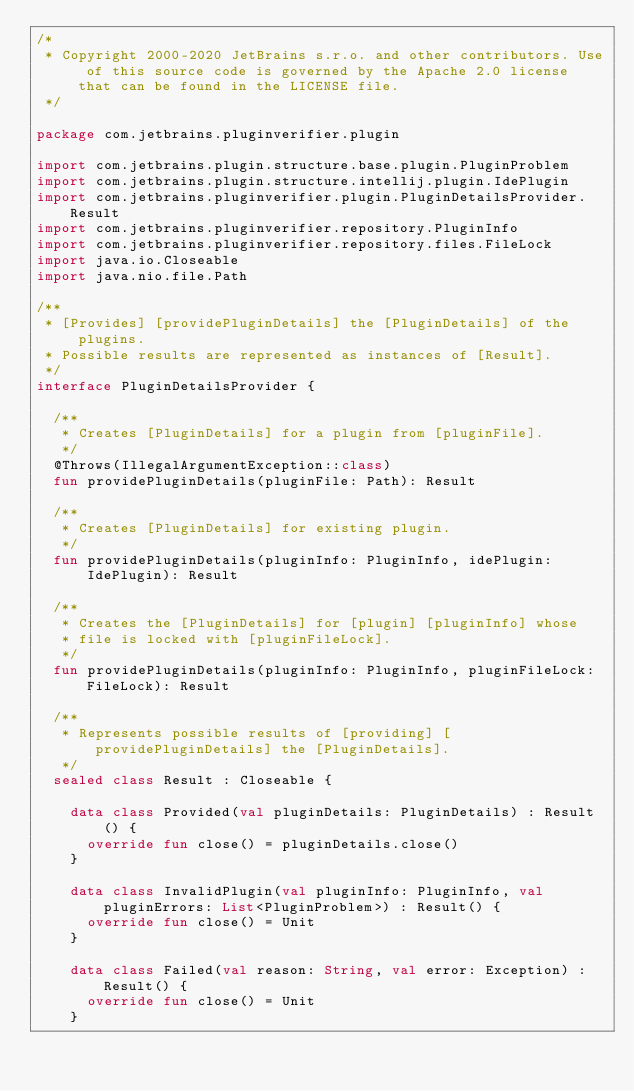Convert code to text. <code><loc_0><loc_0><loc_500><loc_500><_Kotlin_>/*
 * Copyright 2000-2020 JetBrains s.r.o. and other contributors. Use of this source code is governed by the Apache 2.0 license that can be found in the LICENSE file.
 */

package com.jetbrains.pluginverifier.plugin

import com.jetbrains.plugin.structure.base.plugin.PluginProblem
import com.jetbrains.plugin.structure.intellij.plugin.IdePlugin
import com.jetbrains.pluginverifier.plugin.PluginDetailsProvider.Result
import com.jetbrains.pluginverifier.repository.PluginInfo
import com.jetbrains.pluginverifier.repository.files.FileLock
import java.io.Closeable
import java.nio.file.Path

/**
 * [Provides] [providePluginDetails] the [PluginDetails] of the plugins.
 * Possible results are represented as instances of [Result].
 */
interface PluginDetailsProvider {

  /**
   * Creates [PluginDetails] for a plugin from [pluginFile].
   */
  @Throws(IllegalArgumentException::class)
  fun providePluginDetails(pluginFile: Path): Result

  /**
   * Creates [PluginDetails] for existing plugin.
   */
  fun providePluginDetails(pluginInfo: PluginInfo, idePlugin: IdePlugin): Result

  /**
   * Creates the [PluginDetails] for [plugin] [pluginInfo] whose
   * file is locked with [pluginFileLock].
   */
  fun providePluginDetails(pluginInfo: PluginInfo, pluginFileLock: FileLock): Result

  /**
   * Represents possible results of [providing] [providePluginDetails] the [PluginDetails].
   */
  sealed class Result : Closeable {

    data class Provided(val pluginDetails: PluginDetails) : Result() {
      override fun close() = pluginDetails.close()
    }

    data class InvalidPlugin(val pluginInfo: PluginInfo, val pluginErrors: List<PluginProblem>) : Result() {
      override fun close() = Unit
    }

    data class Failed(val reason: String, val error: Exception) : Result() {
      override fun close() = Unit
    }</code> 